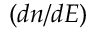<formula> <loc_0><loc_0><loc_500><loc_500>( d n / d E )</formula> 